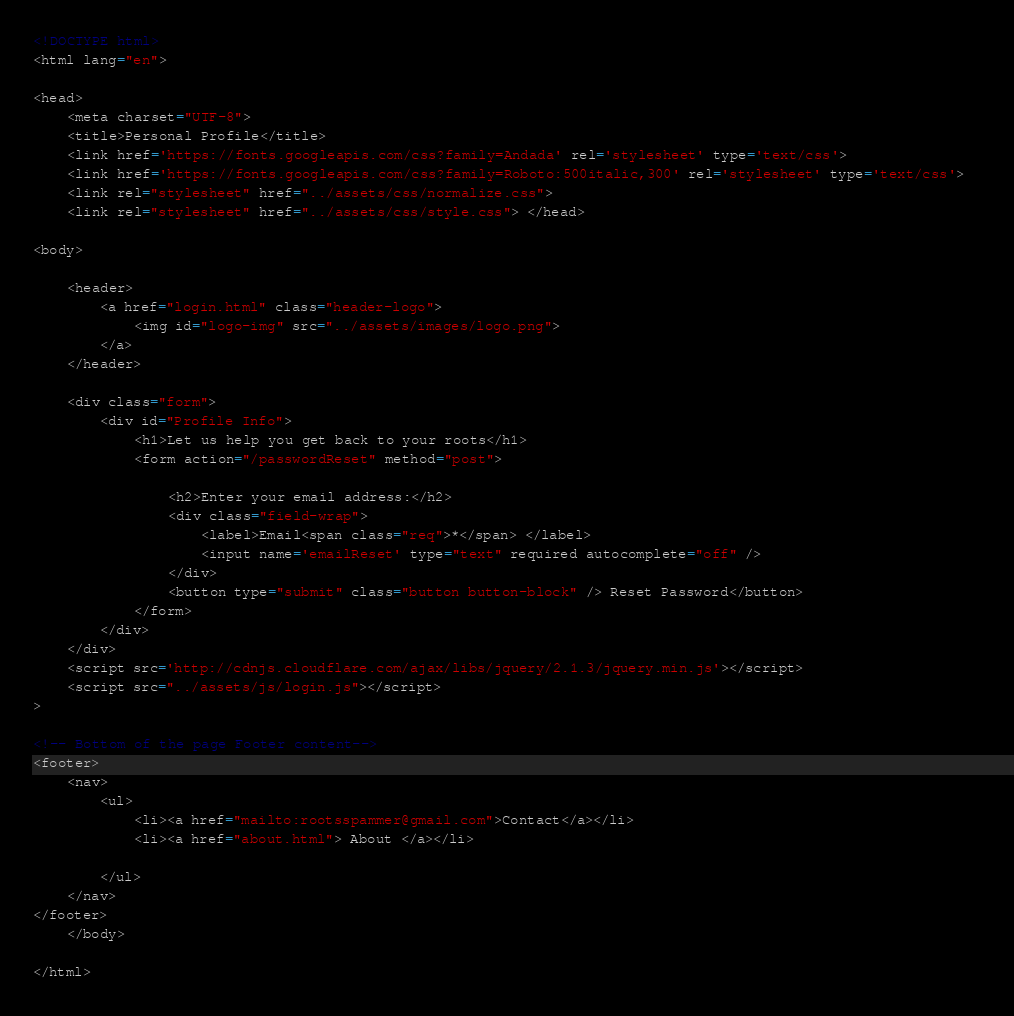Convert code to text. <code><loc_0><loc_0><loc_500><loc_500><_HTML_><!DOCTYPE html>
<html lang="en">

<head>
    <meta charset="UTF-8">
    <title>Personal Profile</title>
    <link href='https://fonts.googleapis.com/css?family=Andada' rel='stylesheet' type='text/css'>
    <link href='https://fonts.googleapis.com/css?family=Roboto:500italic,300' rel='stylesheet' type='text/css'>  
    <link rel="stylesheet" href="../assets/css/normalize.css">
    <link rel="stylesheet" href="../assets/css/style.css"> </head>

<body>

    <header>
        <a href="login.html" class="header-logo">
            <img id="logo-img" src="../assets/images/logo.png">
        </a>
    </header>
    
    <div class="form">
        <div id="Profile Info">
            <h1>Let us help you get back to your roots</h1>
            <form action="/passwordReset" method="post">

                <h2>Enter your email address:</h2>
                <div class="field-wrap">
                    <label>Email<span class="req">*</span> </label>
                    <input name='emailReset' type="text" required autocomplete="off" />
                </div>
                <button type="submit" class="button button-block" /> Reset Password</button>
            </form>
        </div>
    </div>
    <script src='http://cdnjs.cloudflare.com/ajax/libs/jquery/2.1.3/jquery.min.js'></script>
    <script src="../assets/js/login.js"></script>
>

<!-- Bottom of the page Footer content--> 
<footer>
    <nav>
        <ul>
            <li><a href="mailto:rootsspammer@gmail.com">Contact</a></li>
            <li><a href="about.html"> About </a></li>

        </ul>
    </nav>
</footer>
    </body>

</html>
</code> 